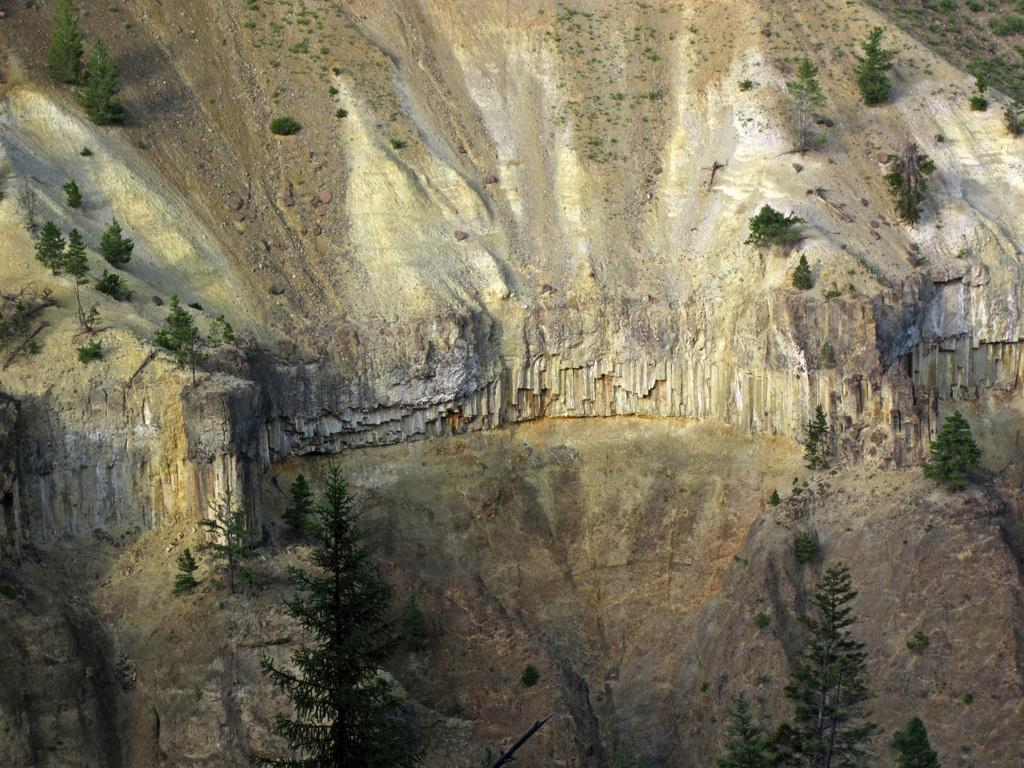What is the main subject of the image? The image appears to depict a mountain. Are there any other natural elements visible in the image? Yes, there are trees visible in the image. How many bridges can be seen crossing the mountain in the image? There are no bridges visible in the image; it depicts a mountain and trees. 